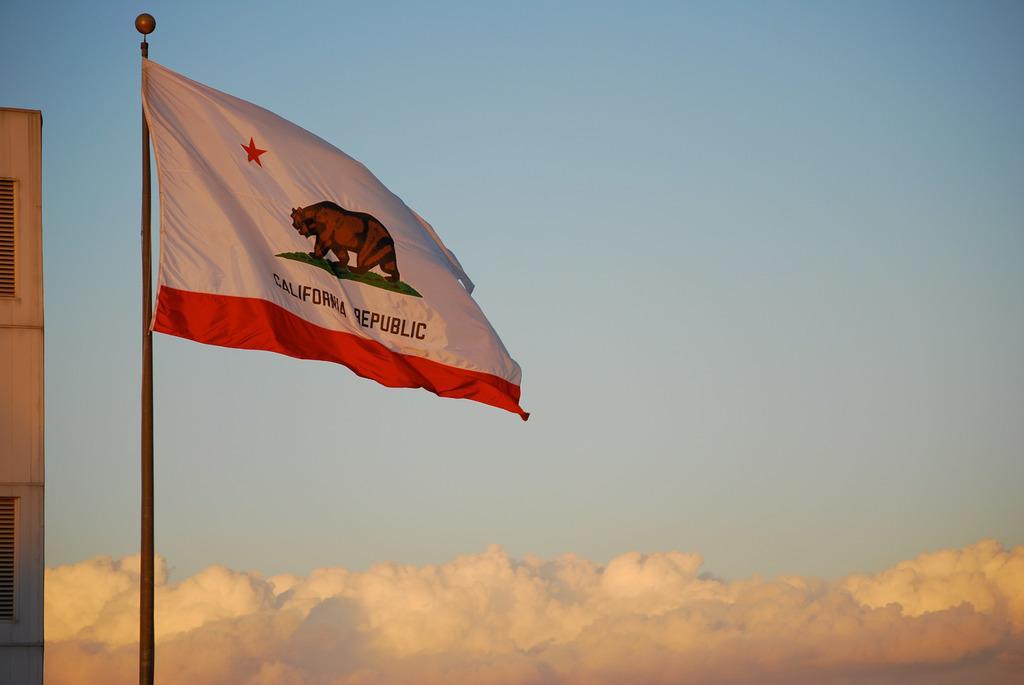How would you summarize this image in a sentence or two? In the left side it is a flag there is a bear symbol on it. In the right side it's a sky. 